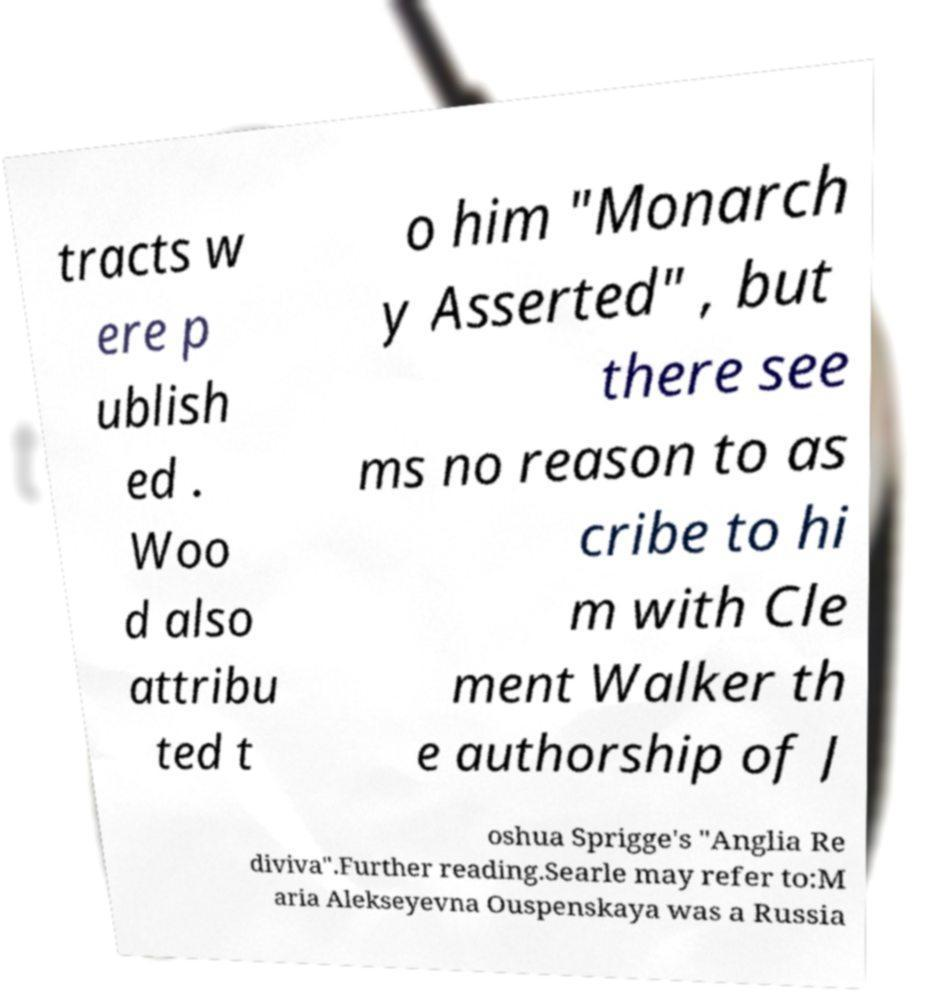What messages or text are displayed in this image? I need them in a readable, typed format. tracts w ere p ublish ed . Woo d also attribu ted t o him "Monarch y Asserted" , but there see ms no reason to as cribe to hi m with Cle ment Walker th e authorship of J oshua Sprigge's "Anglia Re diviva".Further reading.Searle may refer to:M aria Alekseyevna Ouspenskaya was a Russia 